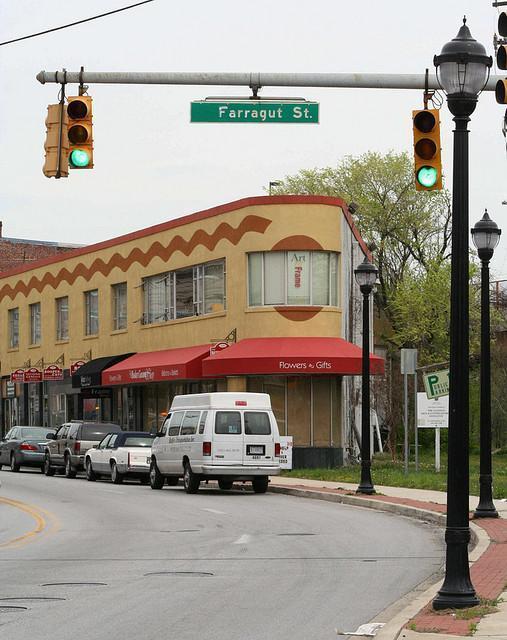How many trucks are visible?
Give a very brief answer. 2. How many cars are visible?
Give a very brief answer. 2. 